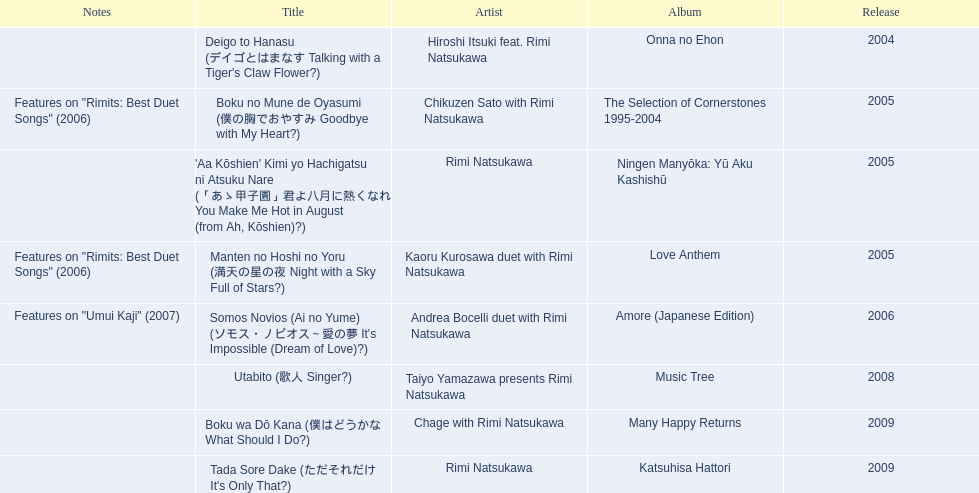Which title of the rimi natsukawa discography was released in the 2004? Deigo to Hanasu (デイゴとはまなす Talking with a Tiger's Claw Flower?). Which title has notes that features on/rimits. best duet songs\2006 Manten no Hoshi no Yoru (満天の星の夜 Night with a Sky Full of Stars?). Which title share the same notes as night with a sky full of stars? Boku no Mune de Oyasumi (僕の胸でおやすみ Goodbye with My Heart?). 